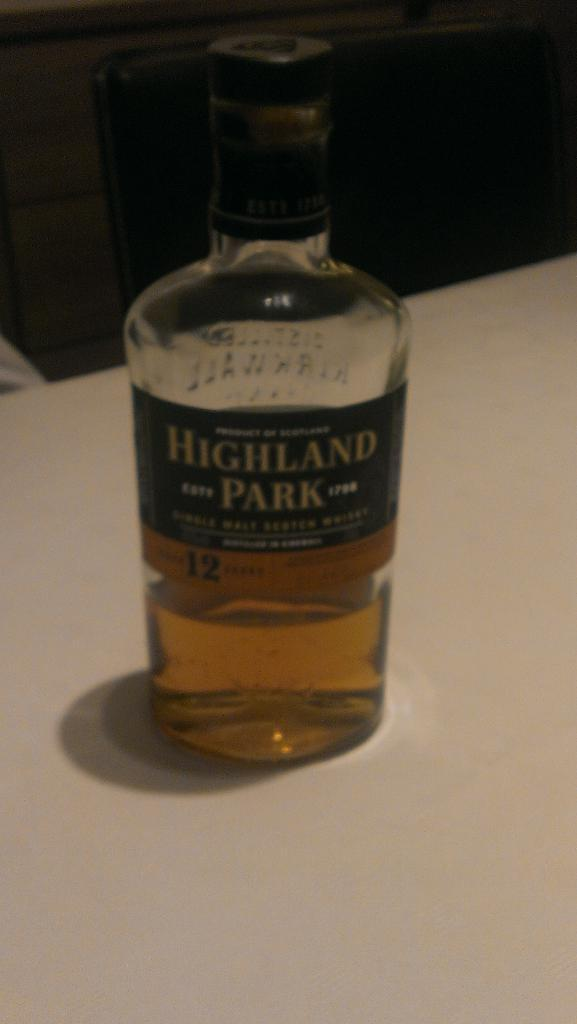<image>
Render a clear and concise summary of the photo. Tall clear bottle labeled Highland Park is sitting on the white surface. 